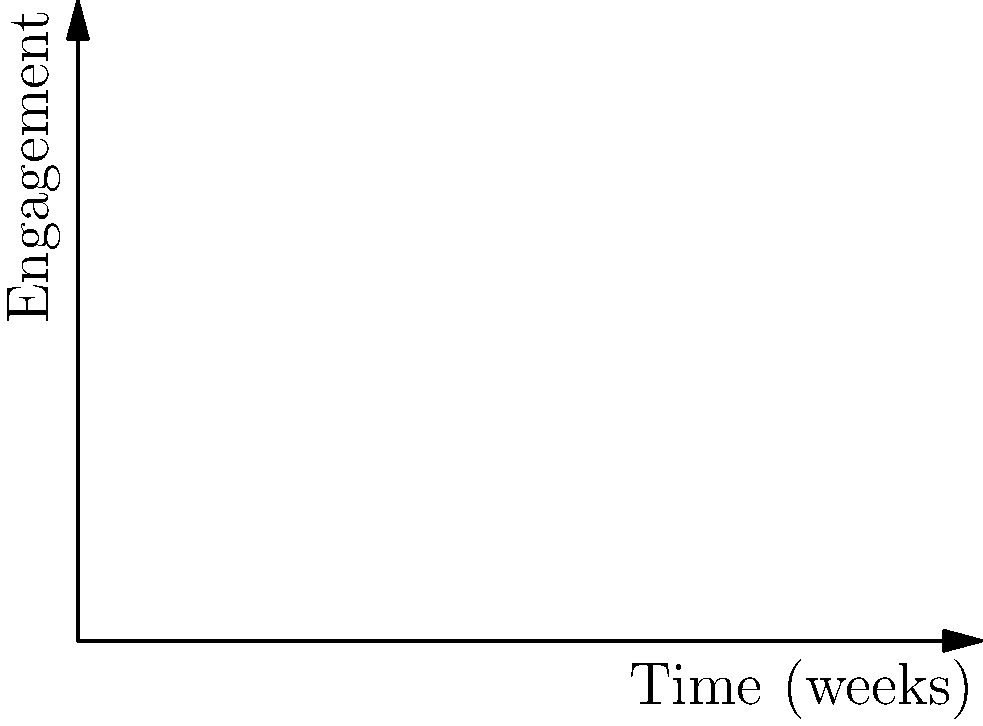The graph shows the social media engagement over time for two different marketing campaigns. At week 5, which campaign has a higher rate of change in engagement, and by how much? Express your answer as a difference in rates of change. To solve this problem, we need to calculate the rate of change (derivative) for each campaign at week 5:

1. For Campaign A: $f(x) = 0.5x^2 + 2x + 10$
   The derivative is $f'(x) = x + 2$
   At week 5: $f'(5) = 5 + 2 = 7$

2. For Campaign B: $g(x) = 20\log(x+1) + 5$
   The derivative is $g'(x) = \frac{20}{x+1}$
   At week 5: $g'(5) = \frac{20}{5+1} = \frac{20}{6} \approx 3.33$

3. Calculate the difference in rates of change:
   $f'(5) - g'(5) = 7 - 3.33 = 3.67$

Therefore, at week 5, Campaign A has a higher rate of change, and the difference in rates of change is approximately 3.67 engagement units per week.
Answer: Campaign A, by 3.67 units/week 